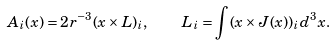Convert formula to latex. <formula><loc_0><loc_0><loc_500><loc_500>A _ { i } ( x ) = 2 r ^ { - 3 } ( x \times L ) _ { i } , \quad L _ { i } = \int ( x \times J ( x ) ) _ { i } d ^ { 3 } x .</formula> 